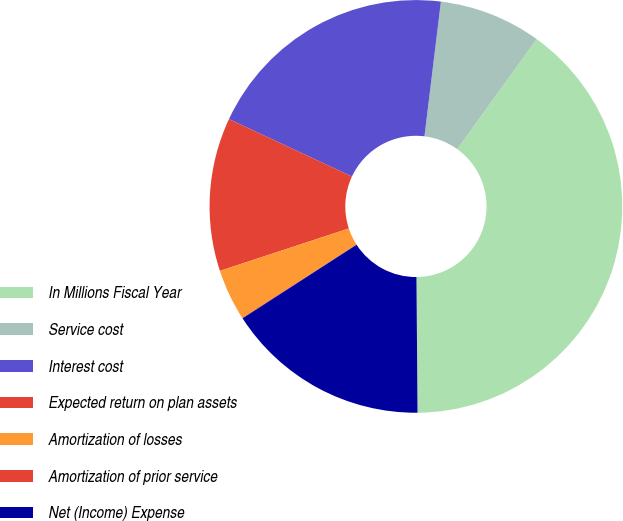Convert chart to OTSL. <chart><loc_0><loc_0><loc_500><loc_500><pie_chart><fcel>In Millions Fiscal Year<fcel>Service cost<fcel>Interest cost<fcel>Expected return on plan assets<fcel>Amortization of losses<fcel>Amortization of prior service<fcel>Net (Income) Expense<nl><fcel>39.93%<fcel>8.02%<fcel>19.98%<fcel>12.01%<fcel>4.03%<fcel>0.04%<fcel>16.0%<nl></chart> 